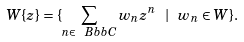<formula> <loc_0><loc_0><loc_500><loc_500>W \{ z \} = \{ \sum _ { n \in { \ B b b C } } w _ { n } z ^ { n } \ | \ w _ { n } \in W \} .</formula> 